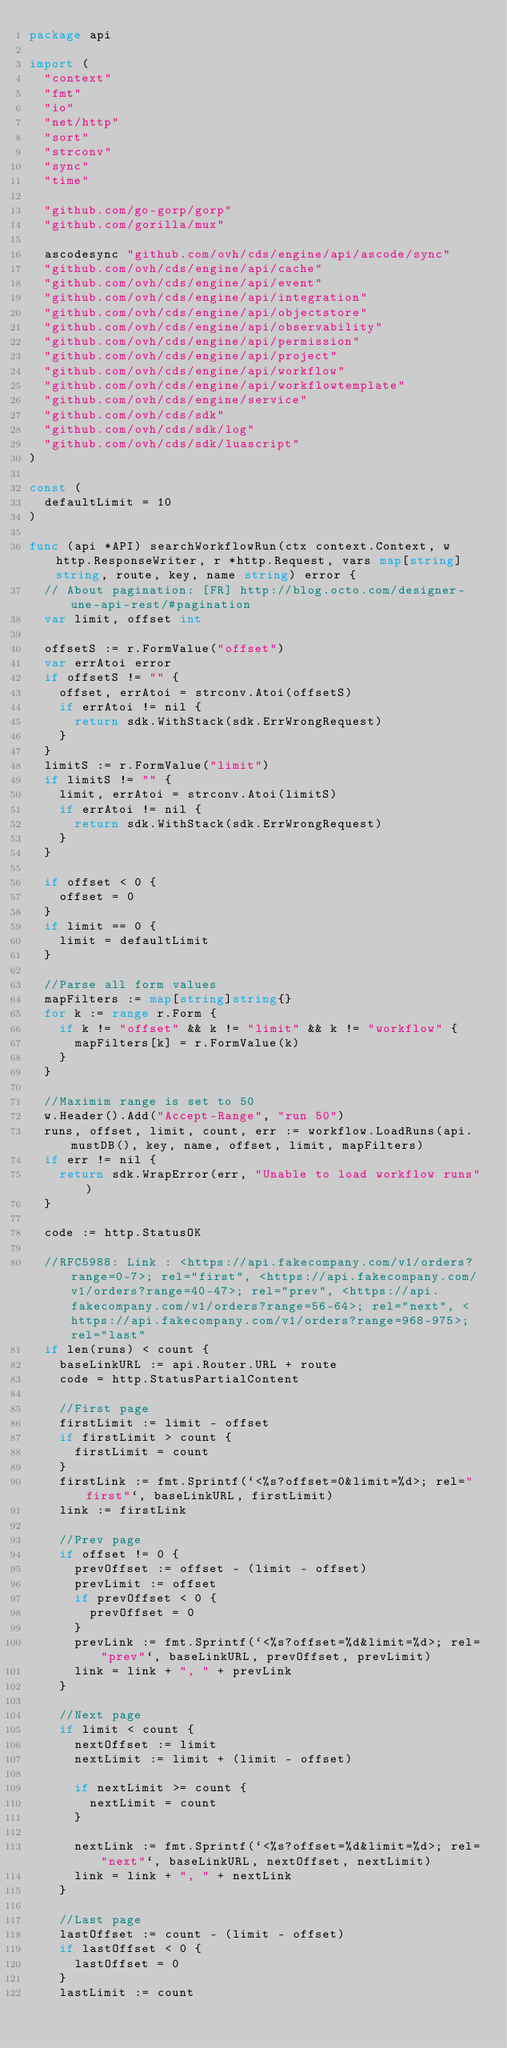Convert code to text. <code><loc_0><loc_0><loc_500><loc_500><_Go_>package api

import (
	"context"
	"fmt"
	"io"
	"net/http"
	"sort"
	"strconv"
	"sync"
	"time"

	"github.com/go-gorp/gorp"
	"github.com/gorilla/mux"

	ascodesync "github.com/ovh/cds/engine/api/ascode/sync"
	"github.com/ovh/cds/engine/api/cache"
	"github.com/ovh/cds/engine/api/event"
	"github.com/ovh/cds/engine/api/integration"
	"github.com/ovh/cds/engine/api/objectstore"
	"github.com/ovh/cds/engine/api/observability"
	"github.com/ovh/cds/engine/api/permission"
	"github.com/ovh/cds/engine/api/project"
	"github.com/ovh/cds/engine/api/workflow"
	"github.com/ovh/cds/engine/api/workflowtemplate"
	"github.com/ovh/cds/engine/service"
	"github.com/ovh/cds/sdk"
	"github.com/ovh/cds/sdk/log"
	"github.com/ovh/cds/sdk/luascript"
)

const (
	defaultLimit = 10
)

func (api *API) searchWorkflowRun(ctx context.Context, w http.ResponseWriter, r *http.Request, vars map[string]string, route, key, name string) error {
	// About pagination: [FR] http://blog.octo.com/designer-une-api-rest/#pagination
	var limit, offset int

	offsetS := r.FormValue("offset")
	var errAtoi error
	if offsetS != "" {
		offset, errAtoi = strconv.Atoi(offsetS)
		if errAtoi != nil {
			return sdk.WithStack(sdk.ErrWrongRequest)
		}
	}
	limitS := r.FormValue("limit")
	if limitS != "" {
		limit, errAtoi = strconv.Atoi(limitS)
		if errAtoi != nil {
			return sdk.WithStack(sdk.ErrWrongRequest)
		}
	}

	if offset < 0 {
		offset = 0
	}
	if limit == 0 {
		limit = defaultLimit
	}

	//Parse all form values
	mapFilters := map[string]string{}
	for k := range r.Form {
		if k != "offset" && k != "limit" && k != "workflow" {
			mapFilters[k] = r.FormValue(k)
		}
	}

	//Maximim range is set to 50
	w.Header().Add("Accept-Range", "run 50")
	runs, offset, limit, count, err := workflow.LoadRuns(api.mustDB(), key, name, offset, limit, mapFilters)
	if err != nil {
		return sdk.WrapError(err, "Unable to load workflow runs")
	}

	code := http.StatusOK

	//RFC5988: Link : <https://api.fakecompany.com/v1/orders?range=0-7>; rel="first", <https://api.fakecompany.com/v1/orders?range=40-47>; rel="prev", <https://api.fakecompany.com/v1/orders?range=56-64>; rel="next", <https://api.fakecompany.com/v1/orders?range=968-975>; rel="last"
	if len(runs) < count {
		baseLinkURL := api.Router.URL + route
		code = http.StatusPartialContent

		//First page
		firstLimit := limit - offset
		if firstLimit > count {
			firstLimit = count
		}
		firstLink := fmt.Sprintf(`<%s?offset=0&limit=%d>; rel="first"`, baseLinkURL, firstLimit)
		link := firstLink

		//Prev page
		if offset != 0 {
			prevOffset := offset - (limit - offset)
			prevLimit := offset
			if prevOffset < 0 {
				prevOffset = 0
			}
			prevLink := fmt.Sprintf(`<%s?offset=%d&limit=%d>; rel="prev"`, baseLinkURL, prevOffset, prevLimit)
			link = link + ", " + prevLink
		}

		//Next page
		if limit < count {
			nextOffset := limit
			nextLimit := limit + (limit - offset)

			if nextLimit >= count {
				nextLimit = count
			}

			nextLink := fmt.Sprintf(`<%s?offset=%d&limit=%d>; rel="next"`, baseLinkURL, nextOffset, nextLimit)
			link = link + ", " + nextLink
		}

		//Last page
		lastOffset := count - (limit - offset)
		if lastOffset < 0 {
			lastOffset = 0
		}
		lastLimit := count</code> 